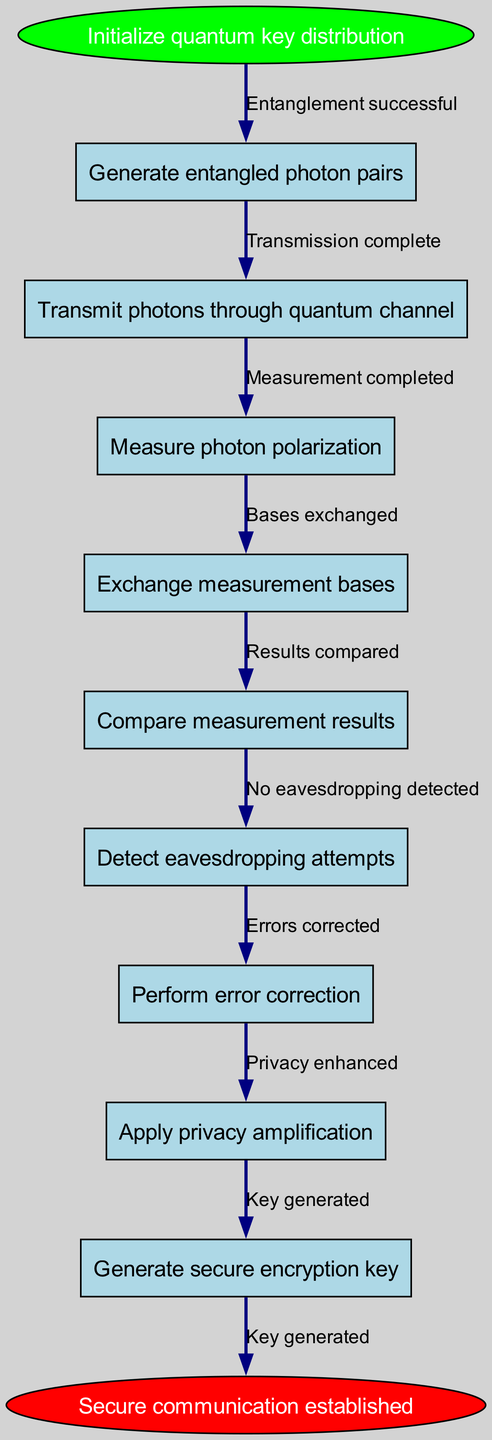What is the first step in the quantum key distribution protocol? The diagram begins with the "Initialize quantum key distribution" as the starting point, indicating that this is the first step in the process.
Answer: Initialize quantum key distribution How many nodes are in the diagram? There are a total of nine nodes represented in the diagram, counting both the starting step and the end step.
Answer: Nine What is the final outcome of the quantum key distribution protocol? The outcome at the end of the diagram is "Secure communication established," which indicates the result of the entire process.
Answer: Secure communication established Which node follows the "Measure photon polarization" node? The diagram shows that after the "Measure photon polarization" node, the next node is "Exchange measurement bases." This is determined by tracing the flow from one step to the next.
Answer: Exchange measurement bases What action occurs after error correction? According to the flow of the diagram, after the "Perform error correction" step, the next action is "Apply privacy amplification," which indicates the sequential process.
Answer: Apply privacy amplification What relationship is shown between "Compare measurement results" and "Detect eavesdropping attempts"? The diagram illustrates that "Compare measurement results" precedes "Detect eavesdropping attempts," indicating that the comparison happens before checking for eavesdropping.
Answer: Precedes What edge connects the "Generate entangled photon pairs" node to its next step? The edge connecting "Generate entangled photon pairs" to the next node is labeled "Entanglement successful," indicating the condition for proceeding to the next step.
Answer: Entanglement successful Which step requires checking for security breaches? The step "Detect eavesdropping attempts" is where security breaches are checked, as indicated by its specific node in the sequence.
Answer: Detect eavesdropping attempts What node comes immediately before the key generation step? The node immediately before the "Generate secure encryption key" step is "Apply privacy amplification," indicating the final arrangement prior to generating the encryption key.
Answer: Apply privacy amplification 